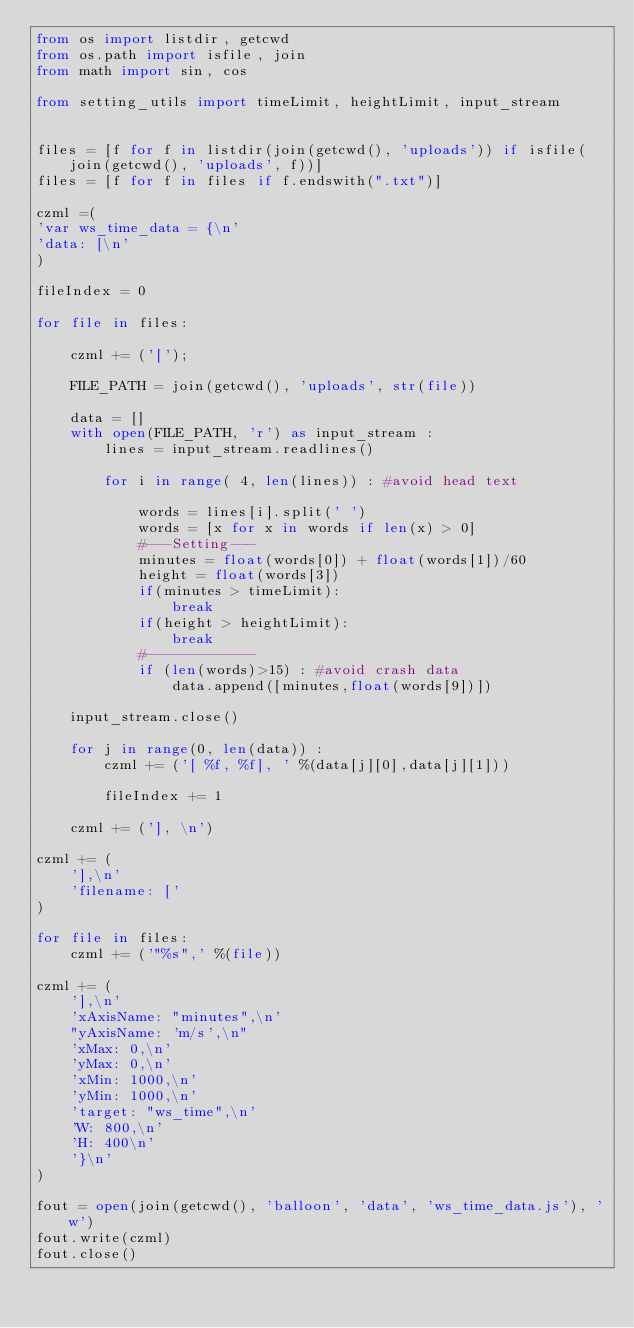<code> <loc_0><loc_0><loc_500><loc_500><_Python_>from os import listdir, getcwd
from os.path import isfile, join
from math import sin, cos

from setting_utils import timeLimit, heightLimit, input_stream


files = [f for f in listdir(join(getcwd(), 'uploads')) if isfile(join(getcwd(), 'uploads', f))]
files = [f for f in files if f.endswith(".txt")]

czml =(
'var ws_time_data = {\n'
'data: [\n'
)

fileIndex = 0

for file in files:

    czml += ('[');

    FILE_PATH = join(getcwd(), 'uploads', str(file))

    data = []
    with open(FILE_PATH, 'r') as input_stream :
        lines = input_stream.readlines()

        for i in range( 4, len(lines)) : #avoid head text

            words = lines[i].split(' ')
            words = [x for x in words if len(x) > 0]
            #---Setting---
            minutes = float(words[0]) + float(words[1])/60
            height = float(words[3])
            if(minutes > timeLimit):
                break
            if(height > heightLimit):
                break
            #-------------
            if (len(words)>15) : #avoid crash data
                data.append([minutes,float(words[9])])

    input_stream.close()

    for j in range(0, len(data)) :
        czml += ('[ %f, %f], ' %(data[j][0],data[j][1]))

        fileIndex += 1

    czml += ('], \n')

czml += (
    '],\n'
    'filename: ['
)

for file in files:
    czml += ('"%s",' %(file))

czml += (
    '],\n'
    'xAxisName: "minutes",\n'
    "yAxisName: 'm/s',\n"
    'xMax: 0,\n'
    'yMax: 0,\n'
    'xMin: 1000,\n'
    'yMin: 1000,\n'
    'target: "ws_time",\n'
    'W: 800,\n'
    'H: 400\n'
    '}\n'
)

fout = open(join(getcwd(), 'balloon', 'data', 'ws_time_data.js'), 'w')
fout.write(czml)
fout.close()
</code> 